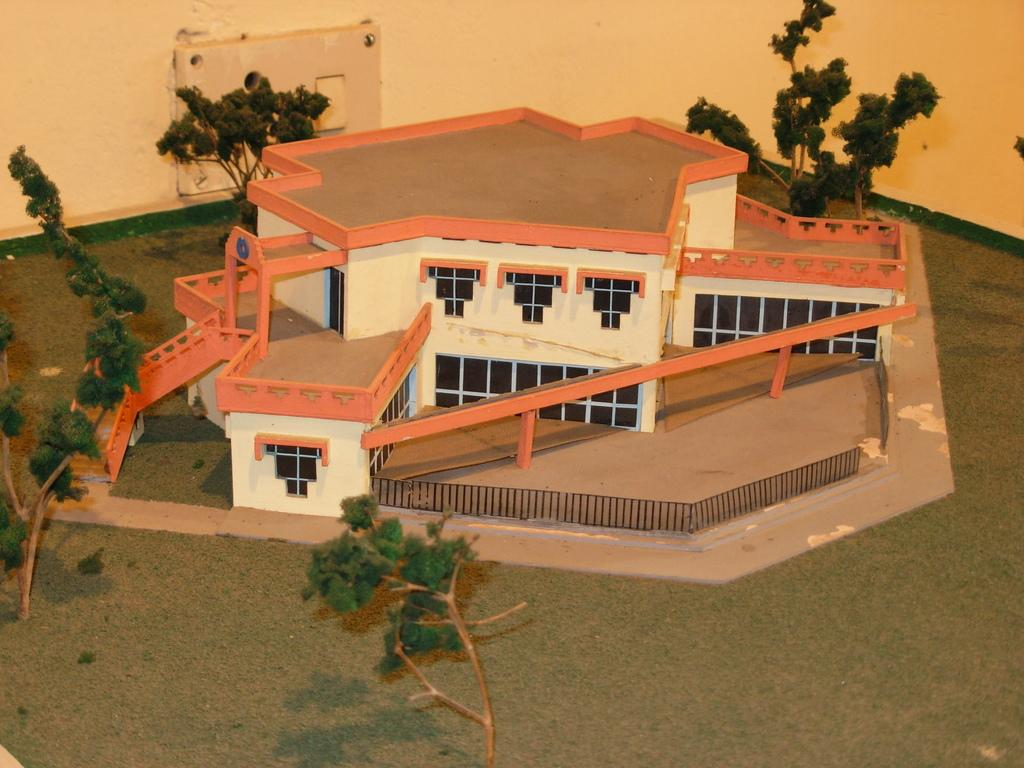What is the main subject of the image? The main subject of the image is a model of a house. Are there any other elements present in the image besides the model house? Yes, there are trees around the model house in the image. How many bricks are used to construct the model house in the image? The image does not provide enough detail to determine the number of bricks used to construct the model house. 